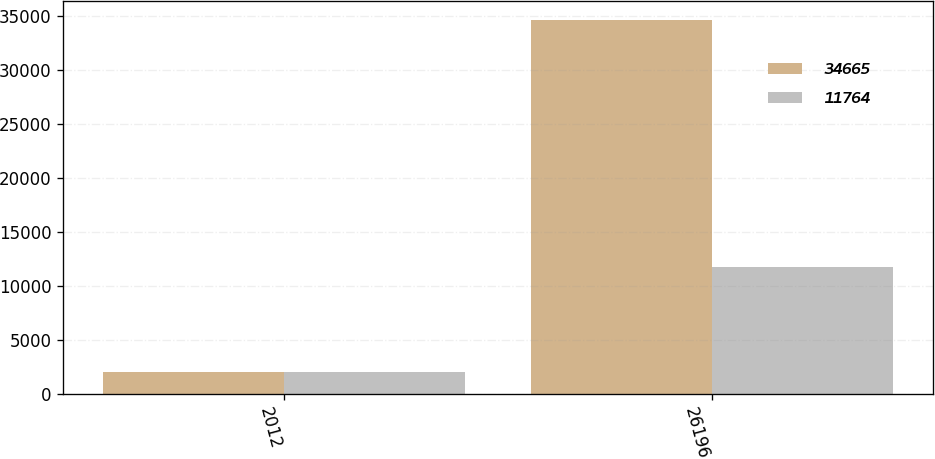<chart> <loc_0><loc_0><loc_500><loc_500><stacked_bar_chart><ecel><fcel>2012<fcel>26196<nl><fcel>34665<fcel>2011<fcel>34665<nl><fcel>11764<fcel>2010<fcel>11764<nl></chart> 